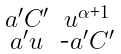<formula> <loc_0><loc_0><loc_500><loc_500>\begin{smallmatrix} a ^ { \prime } C ^ { \prime } & u ^ { \alpha \text {+} 1 } \\ a ^ { \prime } u & \text {-} a ^ { \prime } C ^ { \prime } \end{smallmatrix}</formula> 